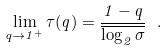Convert formula to latex. <formula><loc_0><loc_0><loc_500><loc_500>\lim _ { q \to 1 ^ { + } } \tau ( q ) = \frac { 1 - q } { \overline { \log _ { 2 } \sigma } } \ .</formula> 